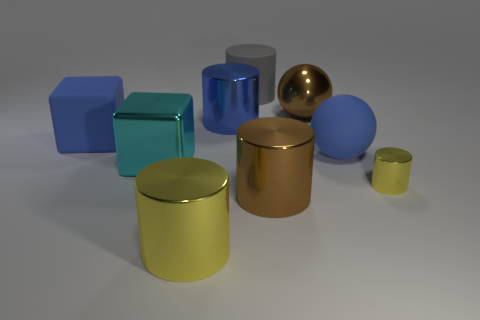Subtract all blue cylinders. How many cylinders are left? 4 Subtract all blue cylinders. How many cylinders are left? 4 Subtract all green cylinders. Subtract all red blocks. How many cylinders are left? 5 Add 1 gray spheres. How many objects exist? 10 Subtract all balls. How many objects are left? 7 Subtract 0 brown cubes. How many objects are left? 9 Subtract all metallic cylinders. Subtract all large balls. How many objects are left? 3 Add 6 gray cylinders. How many gray cylinders are left? 7 Add 6 yellow metal objects. How many yellow metal objects exist? 8 